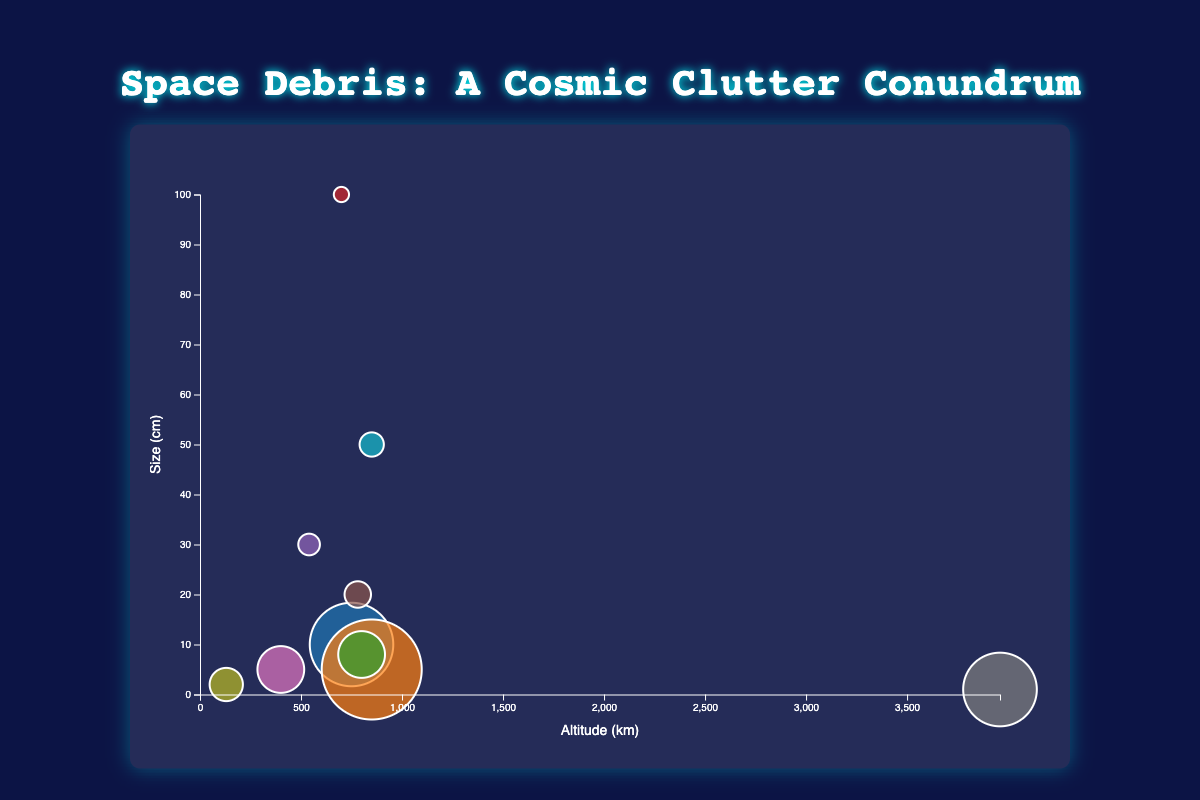How many types of space debris are represented in the bubble chart? By counting the distinct bubbles, we can determine the number of different types of space debris. There are 10 data points representing different debris types.
Answer: 10 What's the altitude range of the space debris in the chart? By examining the x-axis, the debris altitude ranges from the lowest value of 130 km (Tiangong-1 debris) to the highest value of 3960 km (Vanguard 1 debris).
Answer: 130 km to 3960 km Which type of space debris has the largest size in centimeters? The size of the debris is represented by the y-axis. By looking at the highest point on the y-axis, we see that Ariane 5 SYLDA adapter has the largest size at 100 cm.
Answer: Ariane 5 SYLDA adapter Which two types of space debris have the highest number of fragments? The number of fragments is shown by the size of the bubbles. Fengyun-1C and Iridium 33 have the largest bubbles, indicating they have the highest number of fragments. Checking the tooltip data, Fengyun-1C has 3000 fragments, and Iridium 33 has 2000 fragments.
Answer: Fengyun-1C and Iridium 33 What's the altitude difference between the debris with the highest and lowest number of fragments? The largest number of fragments is 3000 (Fengyun-1C at 850 km), and the lowest is 10 (Ariane 5 SYLDA adapter at 700 km). The difference in altitude is 850 km - 700 km.
Answer: 150 km Which type of debris is at the lowest altitude, and what is its altitude? The lowest point on the x-axis indicates the lowest altitude, which is Tiangong-1 debris at 130 km.
Answer: Tiangong-1 debris, 130 km What is the median size of the space debris represented? To find the median size, sort the sizes in ascending order: 1, 2, 5, 5, 8, 10, 20, 30, 50, 100. The middle two values are 8 and 10, so the median is (8 + 10) / 2.
Answer: 9 cm How does the size of ISS debris compare with Hubble Space Telescope debris? ISS debris has a size of 5 cm, and Hubble Space Telescope debris has a size of 30 cm. Since 5 is less than 30, ISS debris is smaller than the Hubble Space Telescope debris.
Answer: Smaller What is the average altitude of all the space debris? Adding all the altitudes: 750 + 850 + 800 + 700 + 540 + 781 + 400 + 3960 + 130 + 850 = 10761 km, then dividing by the number of debris types, which is 10. The average altitude is 10761 / 10.
Answer: 1076.1 km Between Envisat debris and COSMOS 2251 debris, which has more fragments? Envisat debris has 100 fragments, and COSMOS 2251 debris has 500 fragments. Therefore, COSMOS 2251 debris has more fragments.
Answer: COSMOS 2251 